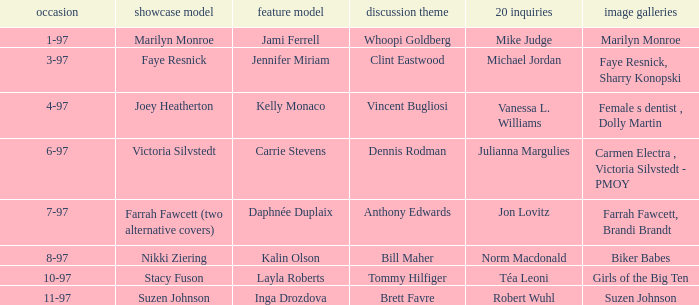When was Kalin Olson listed as  the centerfold model? 8-97. I'm looking to parse the entire table for insights. Could you assist me with that? {'header': ['occasion', 'showcase model', 'feature model', 'discussion theme', '20 inquiries', 'image galleries'], 'rows': [['1-97', 'Marilyn Monroe', 'Jami Ferrell', 'Whoopi Goldberg', 'Mike Judge', 'Marilyn Monroe'], ['3-97', 'Faye Resnick', 'Jennifer Miriam', 'Clint Eastwood', 'Michael Jordan', 'Faye Resnick, Sharry Konopski'], ['4-97', 'Joey Heatherton', 'Kelly Monaco', 'Vincent Bugliosi', 'Vanessa L. Williams', 'Female s dentist , Dolly Martin'], ['6-97', 'Victoria Silvstedt', 'Carrie Stevens', 'Dennis Rodman', 'Julianna Margulies', 'Carmen Electra , Victoria Silvstedt - PMOY'], ['7-97', 'Farrah Fawcett (two alternative covers)', 'Daphnée Duplaix', 'Anthony Edwards', 'Jon Lovitz', 'Farrah Fawcett, Brandi Brandt'], ['8-97', 'Nikki Ziering', 'Kalin Olson', 'Bill Maher', 'Norm Macdonald', 'Biker Babes'], ['10-97', 'Stacy Fuson', 'Layla Roberts', 'Tommy Hilfiger', 'Téa Leoni', 'Girls of the Big Ten'], ['11-97', 'Suzen Johnson', 'Inga Drozdova', 'Brett Favre', 'Robert Wuhl', 'Suzen Johnson']]} 